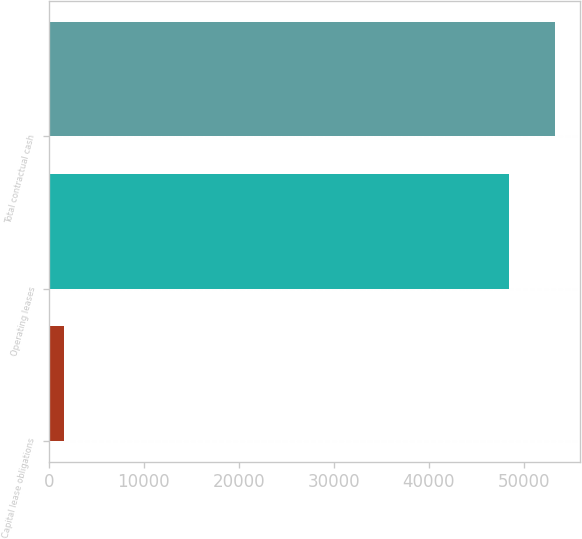<chart> <loc_0><loc_0><loc_500><loc_500><bar_chart><fcel>Capital lease obligations<fcel>Operating leases<fcel>Total contractual cash<nl><fcel>1616<fcel>48450<fcel>53303.8<nl></chart> 